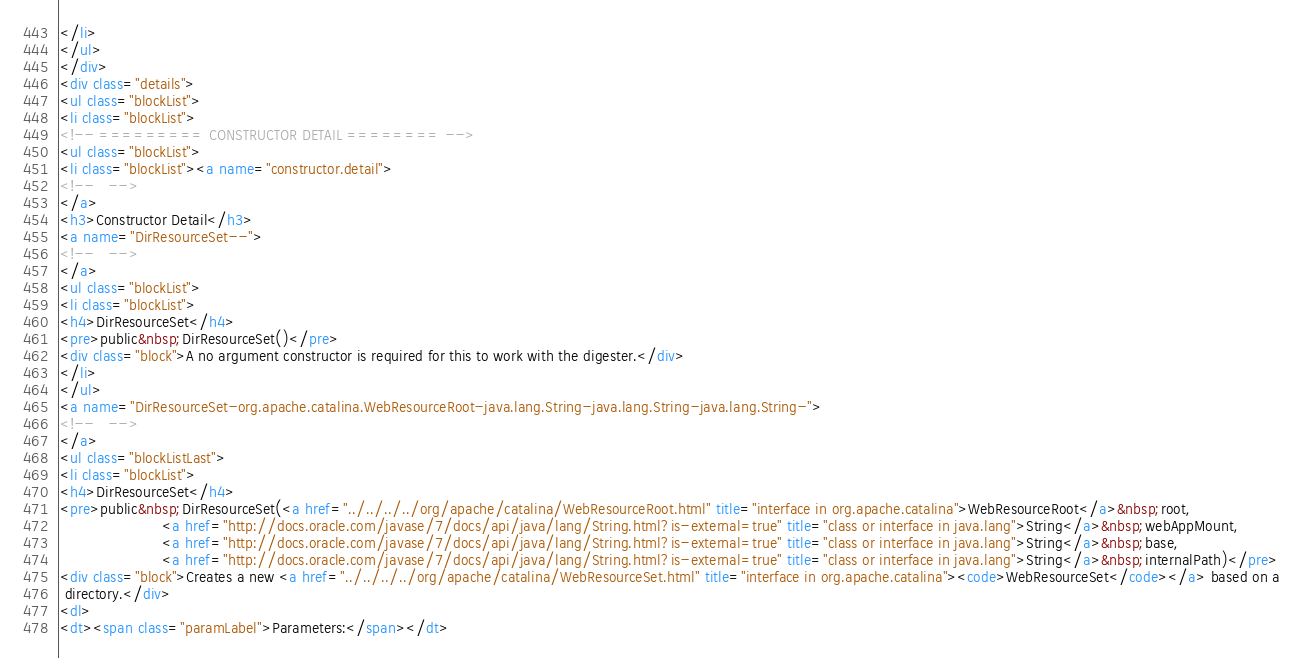<code> <loc_0><loc_0><loc_500><loc_500><_HTML_></li>
</ul>
</div>
<div class="details">
<ul class="blockList">
<li class="blockList">
<!-- ========= CONSTRUCTOR DETAIL ======== -->
<ul class="blockList">
<li class="blockList"><a name="constructor.detail">
<!--   -->
</a>
<h3>Constructor Detail</h3>
<a name="DirResourceSet--">
<!--   -->
</a>
<ul class="blockList">
<li class="blockList">
<h4>DirResourceSet</h4>
<pre>public&nbsp;DirResourceSet()</pre>
<div class="block">A no argument constructor is required for this to work with the digester.</div>
</li>
</ul>
<a name="DirResourceSet-org.apache.catalina.WebResourceRoot-java.lang.String-java.lang.String-java.lang.String-">
<!--   -->
</a>
<ul class="blockListLast">
<li class="blockList">
<h4>DirResourceSet</h4>
<pre>public&nbsp;DirResourceSet(<a href="../../../../org/apache/catalina/WebResourceRoot.html" title="interface in org.apache.catalina">WebResourceRoot</a>&nbsp;root,
                      <a href="http://docs.oracle.com/javase/7/docs/api/java/lang/String.html?is-external=true" title="class or interface in java.lang">String</a>&nbsp;webAppMount,
                      <a href="http://docs.oracle.com/javase/7/docs/api/java/lang/String.html?is-external=true" title="class or interface in java.lang">String</a>&nbsp;base,
                      <a href="http://docs.oracle.com/javase/7/docs/api/java/lang/String.html?is-external=true" title="class or interface in java.lang">String</a>&nbsp;internalPath)</pre>
<div class="block">Creates a new <a href="../../../../org/apache/catalina/WebResourceSet.html" title="interface in org.apache.catalina"><code>WebResourceSet</code></a> based on a
 directory.</div>
<dl>
<dt><span class="paramLabel">Parameters:</span></dt></code> 